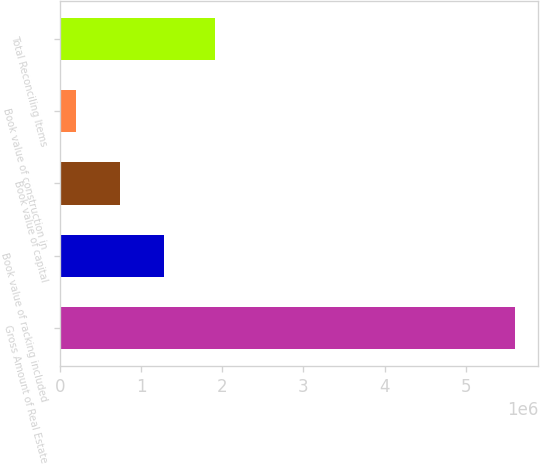Convert chart to OTSL. <chart><loc_0><loc_0><loc_500><loc_500><bar_chart><fcel>Gross Amount of Real Estate<fcel>Book value of racking included<fcel>Book value of capital<fcel>Book value of construction in<fcel>Total Reconciling Items<nl><fcel>5.61228e+06<fcel>1.27947e+06<fcel>737869<fcel>196268<fcel>1.91197e+06<nl></chart> 